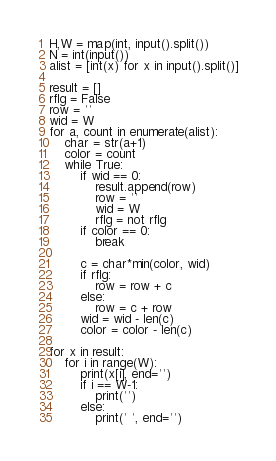Convert code to text. <code><loc_0><loc_0><loc_500><loc_500><_Python_>H,W = map(int, input().split())
N = int(input())
alist = [int(x) for x in input().split()]

result = []
rflg = False
row = ''
wid = W
for a, count in enumerate(alist):
    char = str(a+1)
    color = count
    while True:
        if wid == 0:
            result.append(row)
            row = ''
            wid = W
            rflg = not rflg
        if color == 0:
            break

        c = char*min(color, wid)
        if rflg:
            row = row + c
        else:
            row = c + row
        wid = wid - len(c)
        color = color - len(c)

for x in result:
    for i in range(W):
        print(x[i], end='')
        if i == W-1:
            print('')
        else:
            print(' ', end='')</code> 